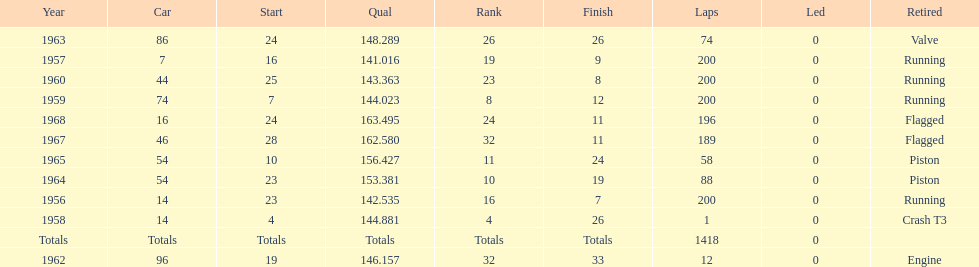How many times was bob veith ranked higher than 10 at an indy 500? 2. 